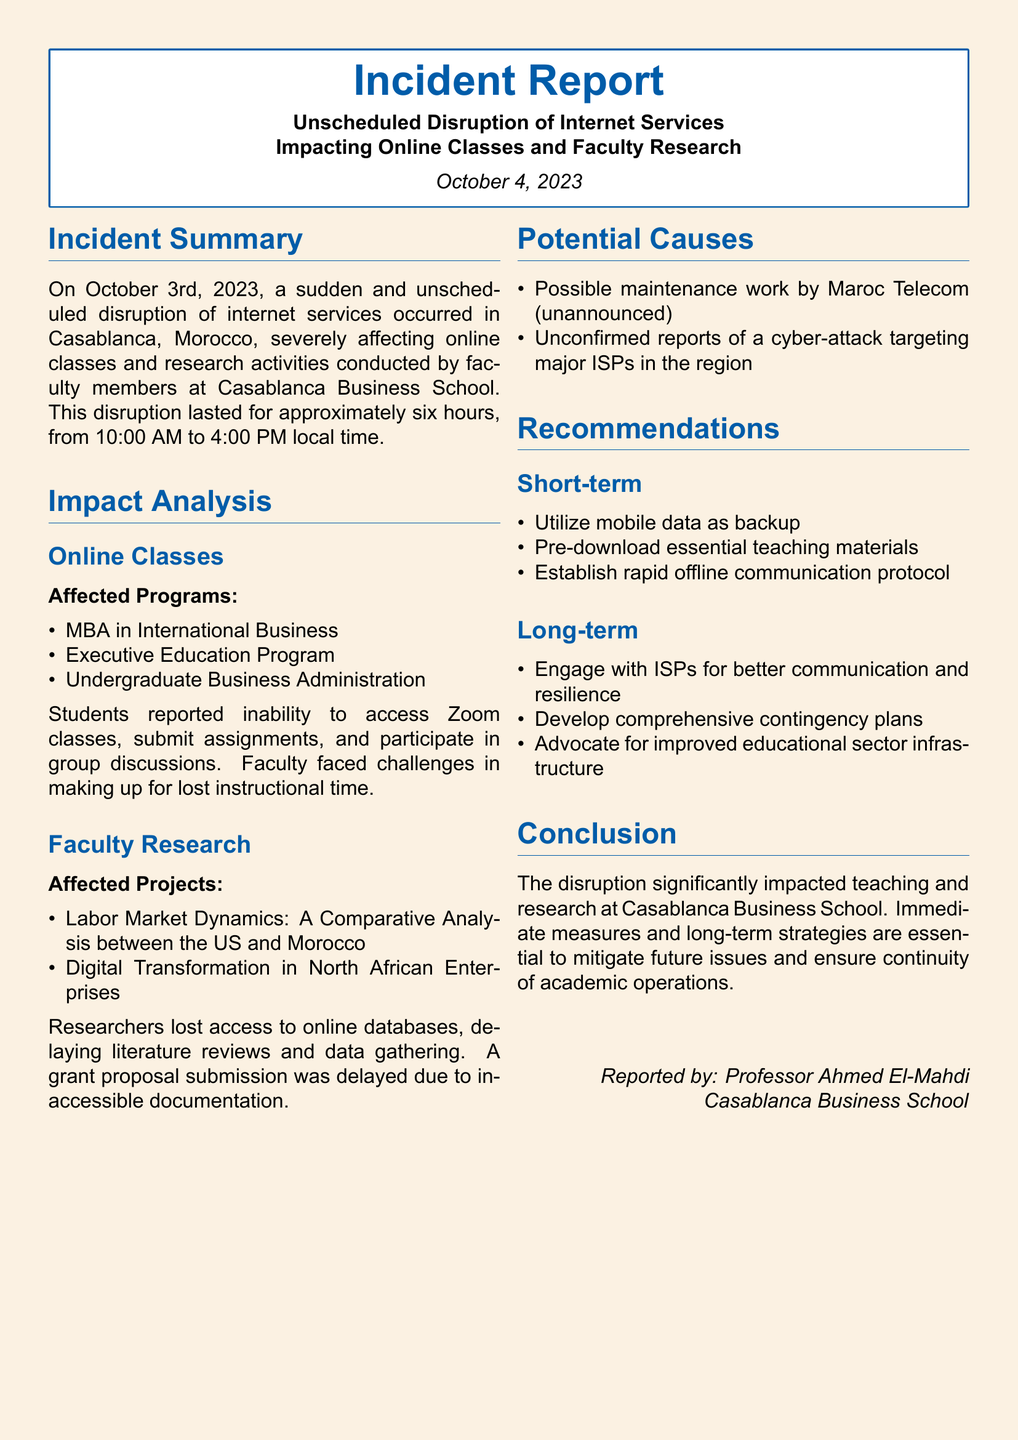What date did the internet disruption occur? The document states that the internet disruption occurred on October 3rd, 2023.
Answer: October 3rd, 2023 How long did the disruption last? The report mentions that the disruption lasted for approximately six hours.
Answer: Six hours Which programs were affected in online classes? A list of affected programs is provided, including the MBA in International Business, Executive Education Program, and Undergraduate Business Administration.
Answer: MBA in International Business, Executive Education Program, Undergraduate Business Administration What impacted faculty research projects? The report identifies several affected projects, including Labor Market Dynamics: A Comparative Analysis between the US and Morocco and Digital Transformation in North African Enterprises.
Answer: Labor Market Dynamics: A Comparative Analysis between the US and Morocco, Digital Transformation in North African Enterprises What are the two potential causes mentioned? The acknowledged potential causes of the incident include possible maintenance work by Maroc Telecom and unconfirmed reports of a cyber-attack.
Answer: Possible maintenance work by Maroc Telecom, unconfirmed reports of a cyber-attack What recommendation is made for short-term action? The report suggests several short-term actions, such as utilizing mobile data as backup and pre-downloading essential teaching materials.
Answer: Utilize mobile data as backup Who reported the incident? According to the document, the incident was reported by Professor Ahmed El-Mahdi.
Answer: Professor Ahmed El-Mahdi What is the primary impact mentioned in the conclusion? The conclusion emphasizes that the disruption significantly impacted teaching and research at Casablanca Business School.
Answer: Significantly impacted teaching and research What is the date of the report? The report itself is dated October 4, 2023.
Answer: October 4, 2023 